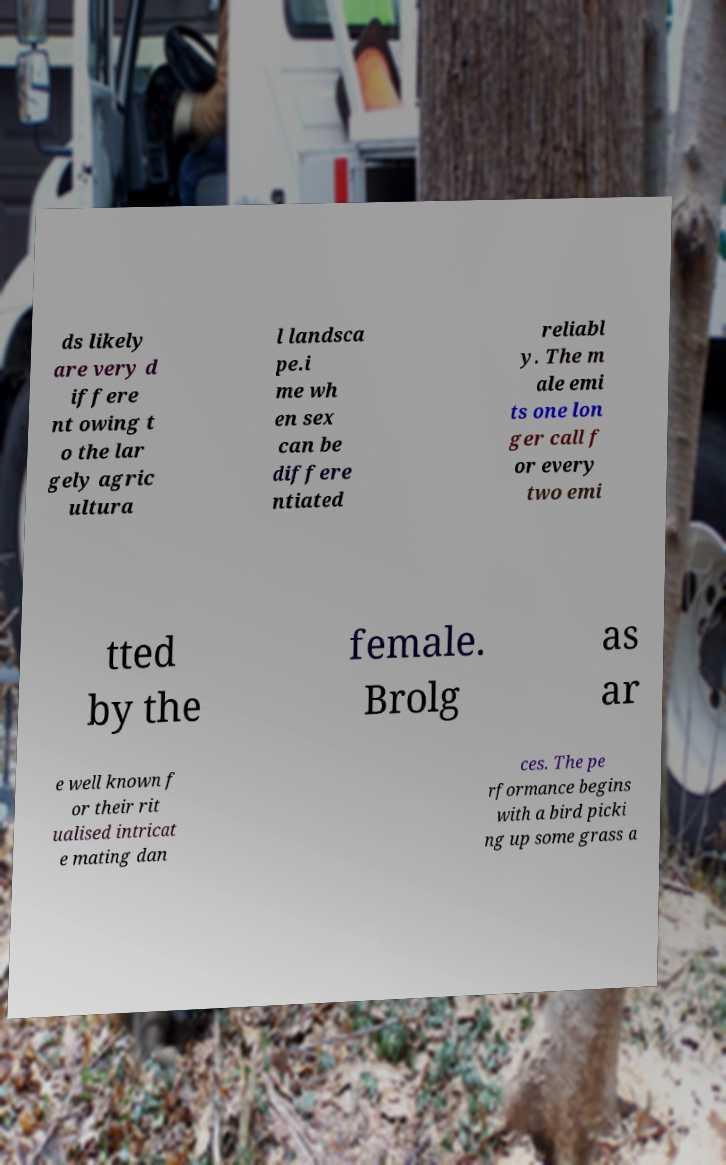I need the written content from this picture converted into text. Can you do that? ds likely are very d iffere nt owing t o the lar gely agric ultura l landsca pe.i me wh en sex can be differe ntiated reliabl y. The m ale emi ts one lon ger call f or every two emi tted by the female. Brolg as ar e well known f or their rit ualised intricat e mating dan ces. The pe rformance begins with a bird picki ng up some grass a 